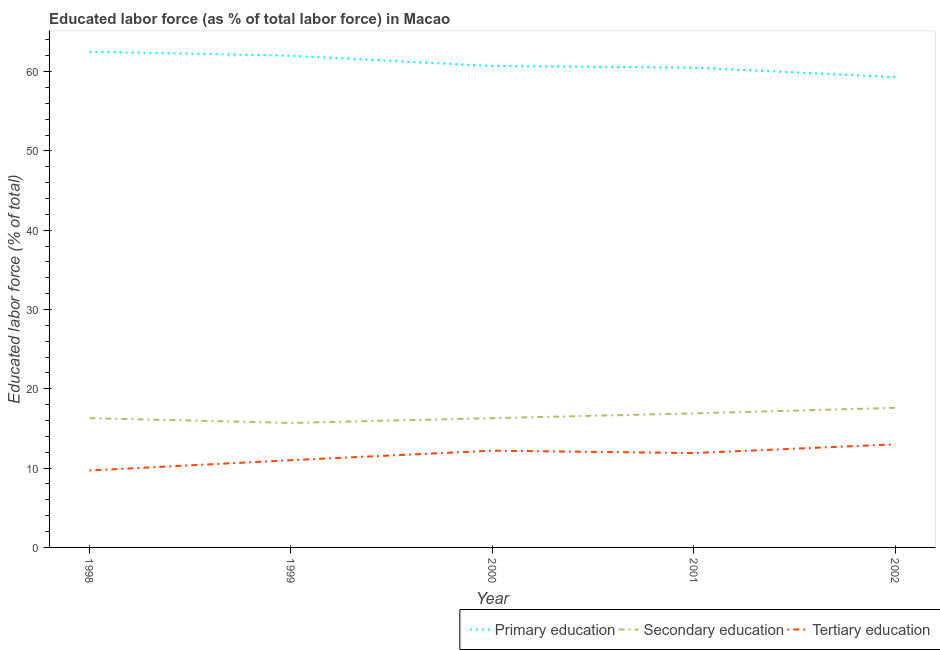Is the number of lines equal to the number of legend labels?
Make the answer very short. Yes. Across all years, what is the maximum percentage of labor force who received tertiary education?
Your answer should be very brief. 13. Across all years, what is the minimum percentage of labor force who received secondary education?
Give a very brief answer. 15.7. In which year was the percentage of labor force who received tertiary education maximum?
Provide a short and direct response. 2002. In which year was the percentage of labor force who received primary education minimum?
Provide a succinct answer. 2002. What is the total percentage of labor force who received tertiary education in the graph?
Offer a very short reply. 57.8. What is the difference between the percentage of labor force who received tertiary education in 2000 and that in 2001?
Provide a succinct answer. 0.3. What is the difference between the percentage of labor force who received secondary education in 1999 and the percentage of labor force who received primary education in 1998?
Offer a very short reply. -46.8. In the year 1999, what is the difference between the percentage of labor force who received tertiary education and percentage of labor force who received primary education?
Keep it short and to the point. -51. In how many years, is the percentage of labor force who received tertiary education greater than 56 %?
Provide a short and direct response. 0. What is the ratio of the percentage of labor force who received primary education in 1998 to that in 2000?
Provide a short and direct response. 1.03. Is the percentage of labor force who received primary education in 1999 less than that in 2001?
Your answer should be very brief. No. What is the difference between the highest and the second highest percentage of labor force who received tertiary education?
Your answer should be very brief. 0.8. What is the difference between the highest and the lowest percentage of labor force who received tertiary education?
Make the answer very short. 3.3. Is the sum of the percentage of labor force who received tertiary education in 1999 and 2002 greater than the maximum percentage of labor force who received primary education across all years?
Ensure brevity in your answer.  No. Does the percentage of labor force who received primary education monotonically increase over the years?
Your response must be concise. No. Is the percentage of labor force who received primary education strictly less than the percentage of labor force who received tertiary education over the years?
Give a very brief answer. No. How many lines are there?
Provide a short and direct response. 3. Does the graph contain any zero values?
Ensure brevity in your answer.  No. What is the title of the graph?
Keep it short and to the point. Educated labor force (as % of total labor force) in Macao. What is the label or title of the Y-axis?
Offer a terse response. Educated labor force (% of total). What is the Educated labor force (% of total) of Primary education in 1998?
Offer a terse response. 62.5. What is the Educated labor force (% of total) of Secondary education in 1998?
Offer a very short reply. 16.3. What is the Educated labor force (% of total) of Tertiary education in 1998?
Make the answer very short. 9.7. What is the Educated labor force (% of total) in Secondary education in 1999?
Ensure brevity in your answer.  15.7. What is the Educated labor force (% of total) of Tertiary education in 1999?
Make the answer very short. 11. What is the Educated labor force (% of total) in Primary education in 2000?
Offer a very short reply. 60.7. What is the Educated labor force (% of total) of Secondary education in 2000?
Offer a very short reply. 16.3. What is the Educated labor force (% of total) in Tertiary education in 2000?
Keep it short and to the point. 12.2. What is the Educated labor force (% of total) of Primary education in 2001?
Provide a short and direct response. 60.5. What is the Educated labor force (% of total) of Secondary education in 2001?
Your response must be concise. 16.9. What is the Educated labor force (% of total) in Tertiary education in 2001?
Ensure brevity in your answer.  11.9. What is the Educated labor force (% of total) in Primary education in 2002?
Offer a very short reply. 59.3. What is the Educated labor force (% of total) in Secondary education in 2002?
Offer a terse response. 17.6. Across all years, what is the maximum Educated labor force (% of total) of Primary education?
Keep it short and to the point. 62.5. Across all years, what is the maximum Educated labor force (% of total) of Secondary education?
Provide a short and direct response. 17.6. Across all years, what is the minimum Educated labor force (% of total) of Primary education?
Provide a succinct answer. 59.3. Across all years, what is the minimum Educated labor force (% of total) of Secondary education?
Give a very brief answer. 15.7. Across all years, what is the minimum Educated labor force (% of total) of Tertiary education?
Your answer should be very brief. 9.7. What is the total Educated labor force (% of total) of Primary education in the graph?
Offer a terse response. 305. What is the total Educated labor force (% of total) of Secondary education in the graph?
Keep it short and to the point. 82.8. What is the total Educated labor force (% of total) of Tertiary education in the graph?
Give a very brief answer. 57.8. What is the difference between the Educated labor force (% of total) in Secondary education in 1998 and that in 1999?
Your answer should be compact. 0.6. What is the difference between the Educated labor force (% of total) in Secondary education in 1998 and that in 2001?
Make the answer very short. -0.6. What is the difference between the Educated labor force (% of total) in Tertiary education in 1998 and that in 2001?
Make the answer very short. -2.2. What is the difference between the Educated labor force (% of total) in Tertiary education in 1998 and that in 2002?
Make the answer very short. -3.3. What is the difference between the Educated labor force (% of total) of Primary education in 1999 and that in 2000?
Provide a succinct answer. 1.3. What is the difference between the Educated labor force (% of total) of Secondary education in 1999 and that in 2000?
Make the answer very short. -0.6. What is the difference between the Educated labor force (% of total) in Primary education in 1999 and that in 2001?
Make the answer very short. 1.5. What is the difference between the Educated labor force (% of total) in Secondary education in 1999 and that in 2001?
Your answer should be compact. -1.2. What is the difference between the Educated labor force (% of total) of Tertiary education in 1999 and that in 2001?
Your response must be concise. -0.9. What is the difference between the Educated labor force (% of total) of Primary education in 1999 and that in 2002?
Your answer should be very brief. 2.7. What is the difference between the Educated labor force (% of total) in Secondary education in 1999 and that in 2002?
Provide a succinct answer. -1.9. What is the difference between the Educated labor force (% of total) in Tertiary education in 1999 and that in 2002?
Offer a terse response. -2. What is the difference between the Educated labor force (% of total) of Primary education in 2000 and that in 2001?
Make the answer very short. 0.2. What is the difference between the Educated labor force (% of total) in Secondary education in 2000 and that in 2001?
Offer a terse response. -0.6. What is the difference between the Educated labor force (% of total) in Primary education in 2000 and that in 2002?
Offer a terse response. 1.4. What is the difference between the Educated labor force (% of total) in Tertiary education in 2001 and that in 2002?
Make the answer very short. -1.1. What is the difference between the Educated labor force (% of total) of Primary education in 1998 and the Educated labor force (% of total) of Secondary education in 1999?
Provide a succinct answer. 46.8. What is the difference between the Educated labor force (% of total) in Primary education in 1998 and the Educated labor force (% of total) in Tertiary education in 1999?
Keep it short and to the point. 51.5. What is the difference between the Educated labor force (% of total) of Secondary education in 1998 and the Educated labor force (% of total) of Tertiary education in 1999?
Your answer should be compact. 5.3. What is the difference between the Educated labor force (% of total) of Primary education in 1998 and the Educated labor force (% of total) of Secondary education in 2000?
Provide a succinct answer. 46.2. What is the difference between the Educated labor force (% of total) in Primary education in 1998 and the Educated labor force (% of total) in Tertiary education in 2000?
Provide a succinct answer. 50.3. What is the difference between the Educated labor force (% of total) of Primary education in 1998 and the Educated labor force (% of total) of Secondary education in 2001?
Keep it short and to the point. 45.6. What is the difference between the Educated labor force (% of total) in Primary education in 1998 and the Educated labor force (% of total) in Tertiary education in 2001?
Offer a terse response. 50.6. What is the difference between the Educated labor force (% of total) of Secondary education in 1998 and the Educated labor force (% of total) of Tertiary education in 2001?
Your answer should be compact. 4.4. What is the difference between the Educated labor force (% of total) in Primary education in 1998 and the Educated labor force (% of total) in Secondary education in 2002?
Offer a terse response. 44.9. What is the difference between the Educated labor force (% of total) in Primary education in 1998 and the Educated labor force (% of total) in Tertiary education in 2002?
Your response must be concise. 49.5. What is the difference between the Educated labor force (% of total) of Primary education in 1999 and the Educated labor force (% of total) of Secondary education in 2000?
Keep it short and to the point. 45.7. What is the difference between the Educated labor force (% of total) in Primary education in 1999 and the Educated labor force (% of total) in Tertiary education in 2000?
Offer a very short reply. 49.8. What is the difference between the Educated labor force (% of total) of Secondary education in 1999 and the Educated labor force (% of total) of Tertiary education in 2000?
Provide a succinct answer. 3.5. What is the difference between the Educated labor force (% of total) of Primary education in 1999 and the Educated labor force (% of total) of Secondary education in 2001?
Your response must be concise. 45.1. What is the difference between the Educated labor force (% of total) in Primary education in 1999 and the Educated labor force (% of total) in Tertiary education in 2001?
Provide a short and direct response. 50.1. What is the difference between the Educated labor force (% of total) of Primary education in 1999 and the Educated labor force (% of total) of Secondary education in 2002?
Ensure brevity in your answer.  44.4. What is the difference between the Educated labor force (% of total) of Secondary education in 1999 and the Educated labor force (% of total) of Tertiary education in 2002?
Ensure brevity in your answer.  2.7. What is the difference between the Educated labor force (% of total) in Primary education in 2000 and the Educated labor force (% of total) in Secondary education in 2001?
Provide a short and direct response. 43.8. What is the difference between the Educated labor force (% of total) in Primary education in 2000 and the Educated labor force (% of total) in Tertiary education in 2001?
Your response must be concise. 48.8. What is the difference between the Educated labor force (% of total) of Primary education in 2000 and the Educated labor force (% of total) of Secondary education in 2002?
Provide a succinct answer. 43.1. What is the difference between the Educated labor force (% of total) of Primary education in 2000 and the Educated labor force (% of total) of Tertiary education in 2002?
Provide a succinct answer. 47.7. What is the difference between the Educated labor force (% of total) of Primary education in 2001 and the Educated labor force (% of total) of Secondary education in 2002?
Your answer should be compact. 42.9. What is the difference between the Educated labor force (% of total) of Primary education in 2001 and the Educated labor force (% of total) of Tertiary education in 2002?
Provide a short and direct response. 47.5. What is the average Educated labor force (% of total) of Primary education per year?
Keep it short and to the point. 61. What is the average Educated labor force (% of total) in Secondary education per year?
Your response must be concise. 16.56. What is the average Educated labor force (% of total) in Tertiary education per year?
Make the answer very short. 11.56. In the year 1998, what is the difference between the Educated labor force (% of total) of Primary education and Educated labor force (% of total) of Secondary education?
Offer a terse response. 46.2. In the year 1998, what is the difference between the Educated labor force (% of total) of Primary education and Educated labor force (% of total) of Tertiary education?
Provide a succinct answer. 52.8. In the year 1999, what is the difference between the Educated labor force (% of total) of Primary education and Educated labor force (% of total) of Secondary education?
Keep it short and to the point. 46.3. In the year 1999, what is the difference between the Educated labor force (% of total) of Primary education and Educated labor force (% of total) of Tertiary education?
Offer a very short reply. 51. In the year 1999, what is the difference between the Educated labor force (% of total) in Secondary education and Educated labor force (% of total) in Tertiary education?
Offer a very short reply. 4.7. In the year 2000, what is the difference between the Educated labor force (% of total) of Primary education and Educated labor force (% of total) of Secondary education?
Give a very brief answer. 44.4. In the year 2000, what is the difference between the Educated labor force (% of total) of Primary education and Educated labor force (% of total) of Tertiary education?
Provide a short and direct response. 48.5. In the year 2001, what is the difference between the Educated labor force (% of total) of Primary education and Educated labor force (% of total) of Secondary education?
Keep it short and to the point. 43.6. In the year 2001, what is the difference between the Educated labor force (% of total) of Primary education and Educated labor force (% of total) of Tertiary education?
Your response must be concise. 48.6. In the year 2002, what is the difference between the Educated labor force (% of total) of Primary education and Educated labor force (% of total) of Secondary education?
Provide a short and direct response. 41.7. In the year 2002, what is the difference between the Educated labor force (% of total) of Primary education and Educated labor force (% of total) of Tertiary education?
Offer a very short reply. 46.3. In the year 2002, what is the difference between the Educated labor force (% of total) of Secondary education and Educated labor force (% of total) of Tertiary education?
Keep it short and to the point. 4.6. What is the ratio of the Educated labor force (% of total) in Secondary education in 1998 to that in 1999?
Give a very brief answer. 1.04. What is the ratio of the Educated labor force (% of total) in Tertiary education in 1998 to that in 1999?
Make the answer very short. 0.88. What is the ratio of the Educated labor force (% of total) in Primary education in 1998 to that in 2000?
Your answer should be compact. 1.03. What is the ratio of the Educated labor force (% of total) of Tertiary education in 1998 to that in 2000?
Offer a terse response. 0.8. What is the ratio of the Educated labor force (% of total) in Primary education in 1998 to that in 2001?
Offer a terse response. 1.03. What is the ratio of the Educated labor force (% of total) in Secondary education in 1998 to that in 2001?
Give a very brief answer. 0.96. What is the ratio of the Educated labor force (% of total) of Tertiary education in 1998 to that in 2001?
Make the answer very short. 0.82. What is the ratio of the Educated labor force (% of total) in Primary education in 1998 to that in 2002?
Give a very brief answer. 1.05. What is the ratio of the Educated labor force (% of total) of Secondary education in 1998 to that in 2002?
Your answer should be compact. 0.93. What is the ratio of the Educated labor force (% of total) in Tertiary education in 1998 to that in 2002?
Offer a very short reply. 0.75. What is the ratio of the Educated labor force (% of total) of Primary education in 1999 to that in 2000?
Your answer should be compact. 1.02. What is the ratio of the Educated labor force (% of total) of Secondary education in 1999 to that in 2000?
Your response must be concise. 0.96. What is the ratio of the Educated labor force (% of total) of Tertiary education in 1999 to that in 2000?
Ensure brevity in your answer.  0.9. What is the ratio of the Educated labor force (% of total) of Primary education in 1999 to that in 2001?
Provide a succinct answer. 1.02. What is the ratio of the Educated labor force (% of total) in Secondary education in 1999 to that in 2001?
Ensure brevity in your answer.  0.93. What is the ratio of the Educated labor force (% of total) of Tertiary education in 1999 to that in 2001?
Your answer should be very brief. 0.92. What is the ratio of the Educated labor force (% of total) of Primary education in 1999 to that in 2002?
Make the answer very short. 1.05. What is the ratio of the Educated labor force (% of total) of Secondary education in 1999 to that in 2002?
Make the answer very short. 0.89. What is the ratio of the Educated labor force (% of total) in Tertiary education in 1999 to that in 2002?
Keep it short and to the point. 0.85. What is the ratio of the Educated labor force (% of total) in Primary education in 2000 to that in 2001?
Your answer should be very brief. 1. What is the ratio of the Educated labor force (% of total) of Secondary education in 2000 to that in 2001?
Provide a short and direct response. 0.96. What is the ratio of the Educated labor force (% of total) of Tertiary education in 2000 to that in 2001?
Your response must be concise. 1.03. What is the ratio of the Educated labor force (% of total) in Primary education in 2000 to that in 2002?
Provide a short and direct response. 1.02. What is the ratio of the Educated labor force (% of total) in Secondary education in 2000 to that in 2002?
Make the answer very short. 0.93. What is the ratio of the Educated labor force (% of total) of Tertiary education in 2000 to that in 2002?
Ensure brevity in your answer.  0.94. What is the ratio of the Educated labor force (% of total) of Primary education in 2001 to that in 2002?
Offer a terse response. 1.02. What is the ratio of the Educated labor force (% of total) of Secondary education in 2001 to that in 2002?
Offer a terse response. 0.96. What is the ratio of the Educated labor force (% of total) in Tertiary education in 2001 to that in 2002?
Provide a short and direct response. 0.92. What is the difference between the highest and the lowest Educated labor force (% of total) of Secondary education?
Provide a succinct answer. 1.9. What is the difference between the highest and the lowest Educated labor force (% of total) in Tertiary education?
Keep it short and to the point. 3.3. 